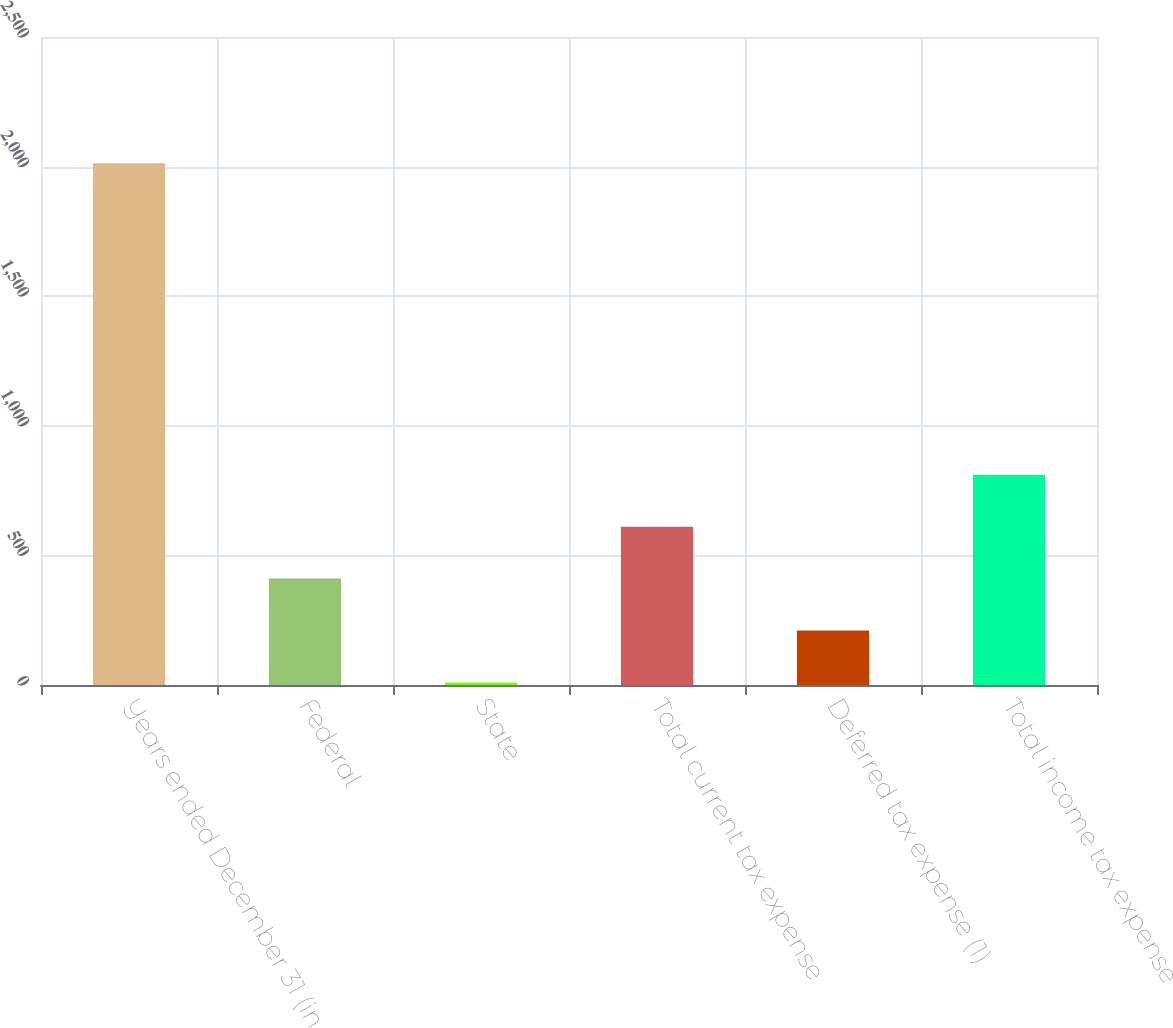Convert chart. <chart><loc_0><loc_0><loc_500><loc_500><bar_chart><fcel>Years ended December 31 (in<fcel>Federal<fcel>State<fcel>Total current tax expense<fcel>Deferred tax expense (1)<fcel>Total income tax expense<nl><fcel>2013<fcel>410.44<fcel>9.8<fcel>610.76<fcel>210.12<fcel>811.08<nl></chart> 